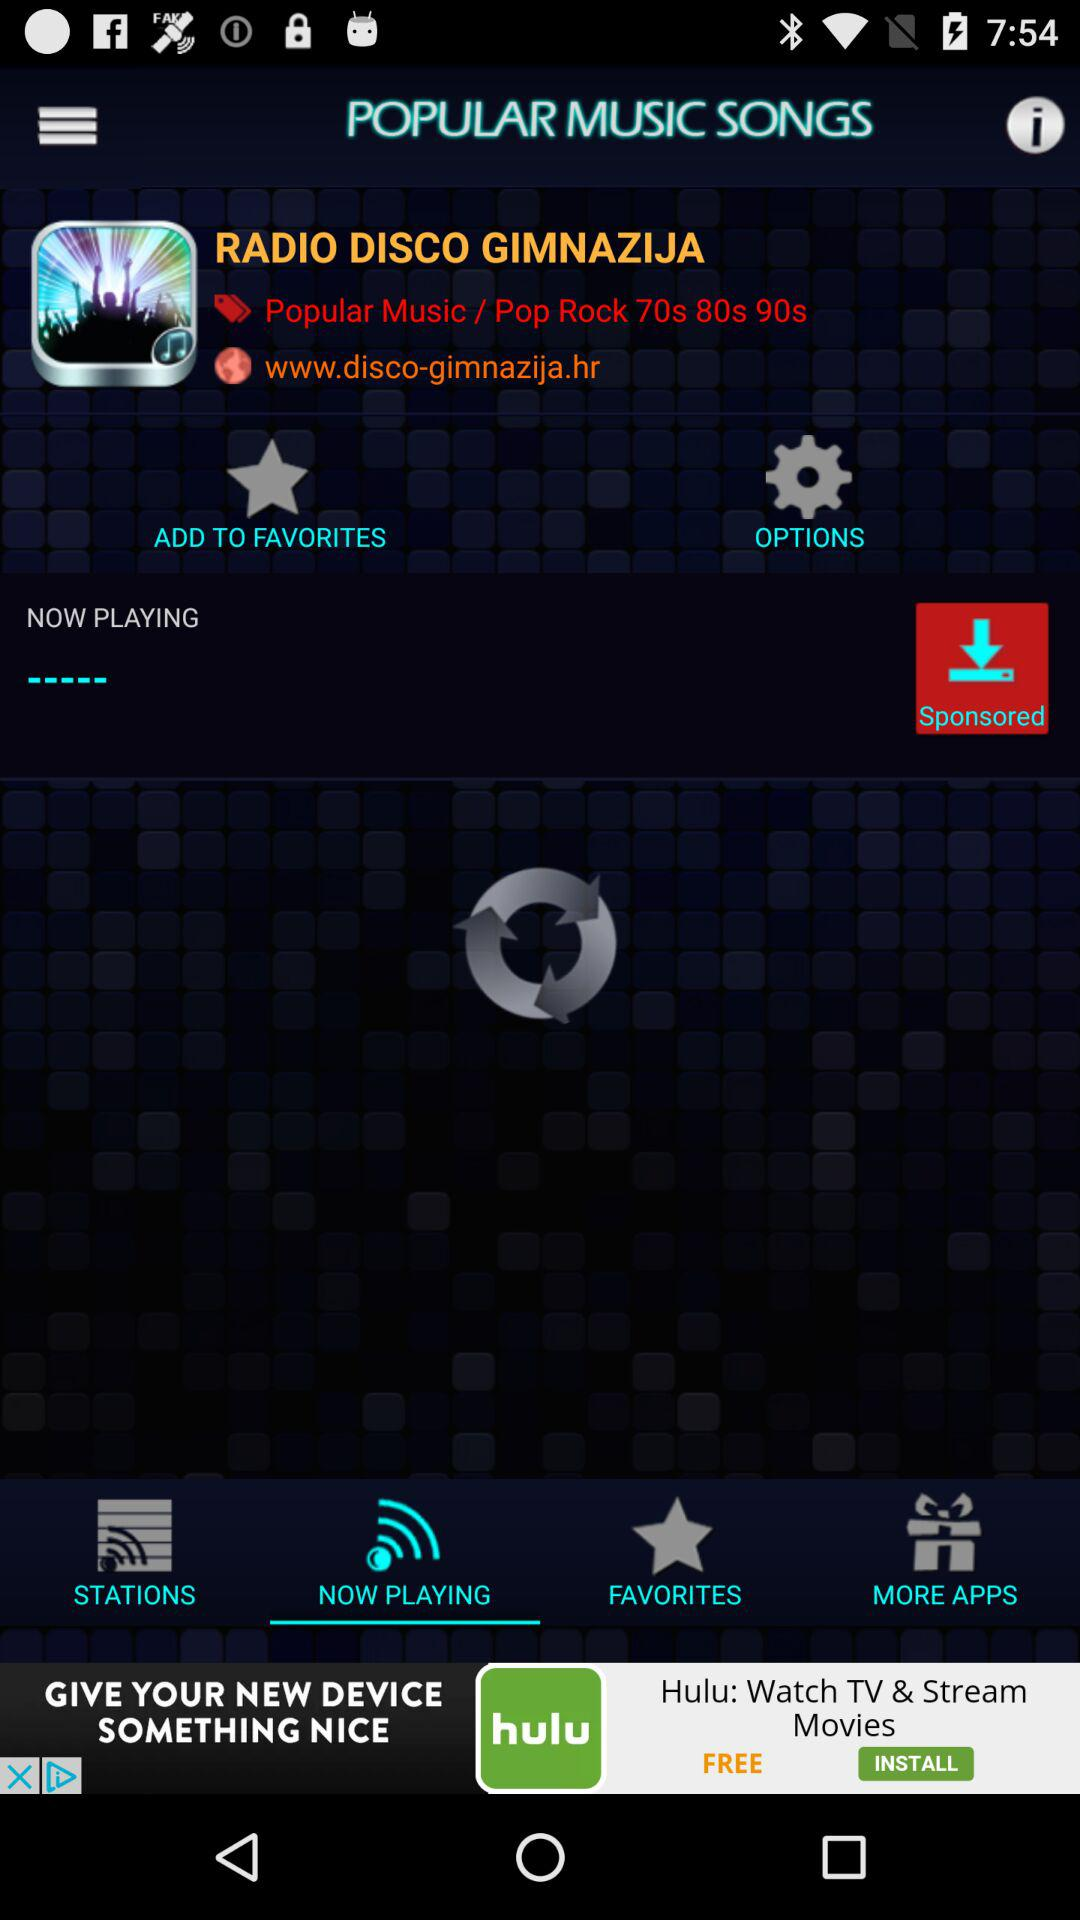Which tab is selected? The selected tab is "NOW PLAYING". 